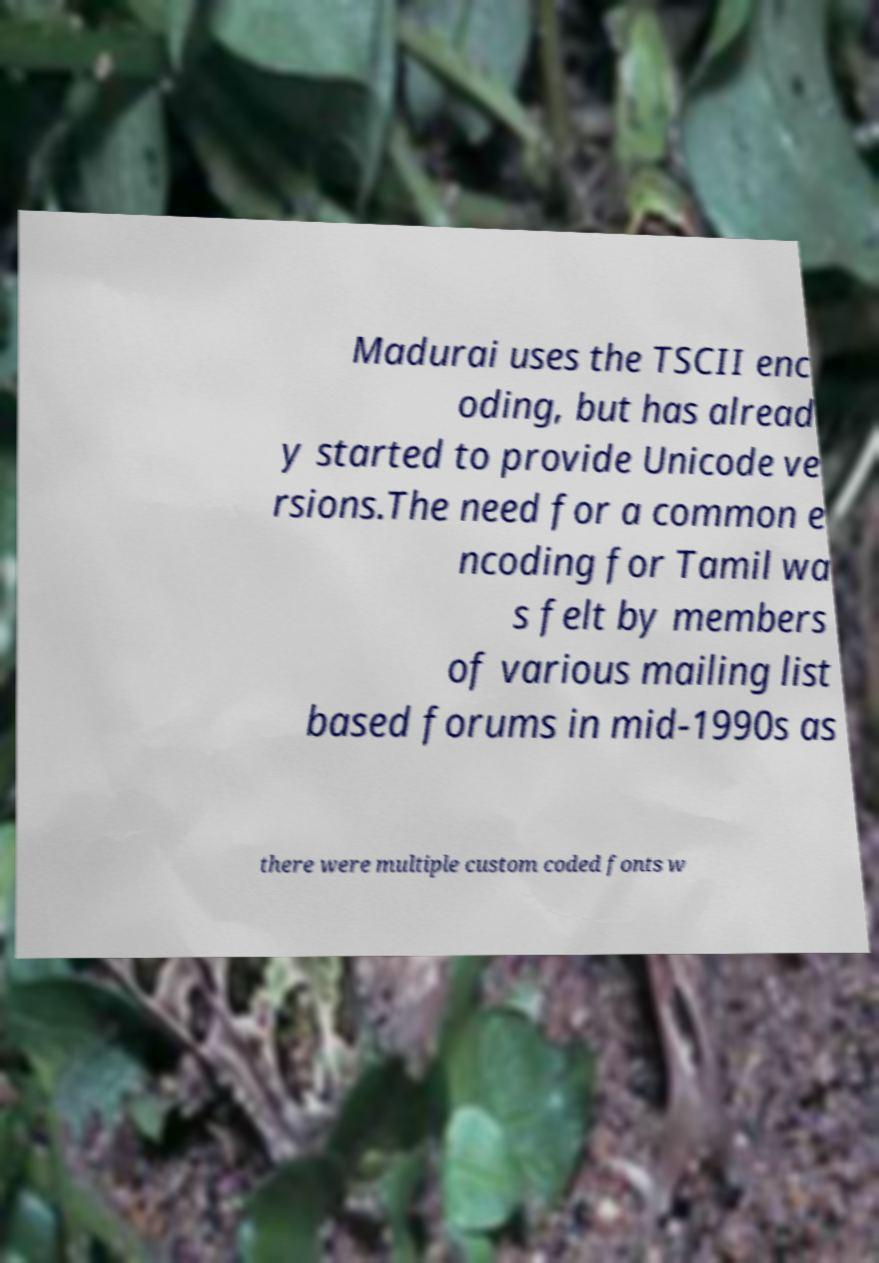Can you accurately transcribe the text from the provided image for me? Madurai uses the TSCII enc oding, but has alread y started to provide Unicode ve rsions.The need for a common e ncoding for Tamil wa s felt by members of various mailing list based forums in mid-1990s as there were multiple custom coded fonts w 